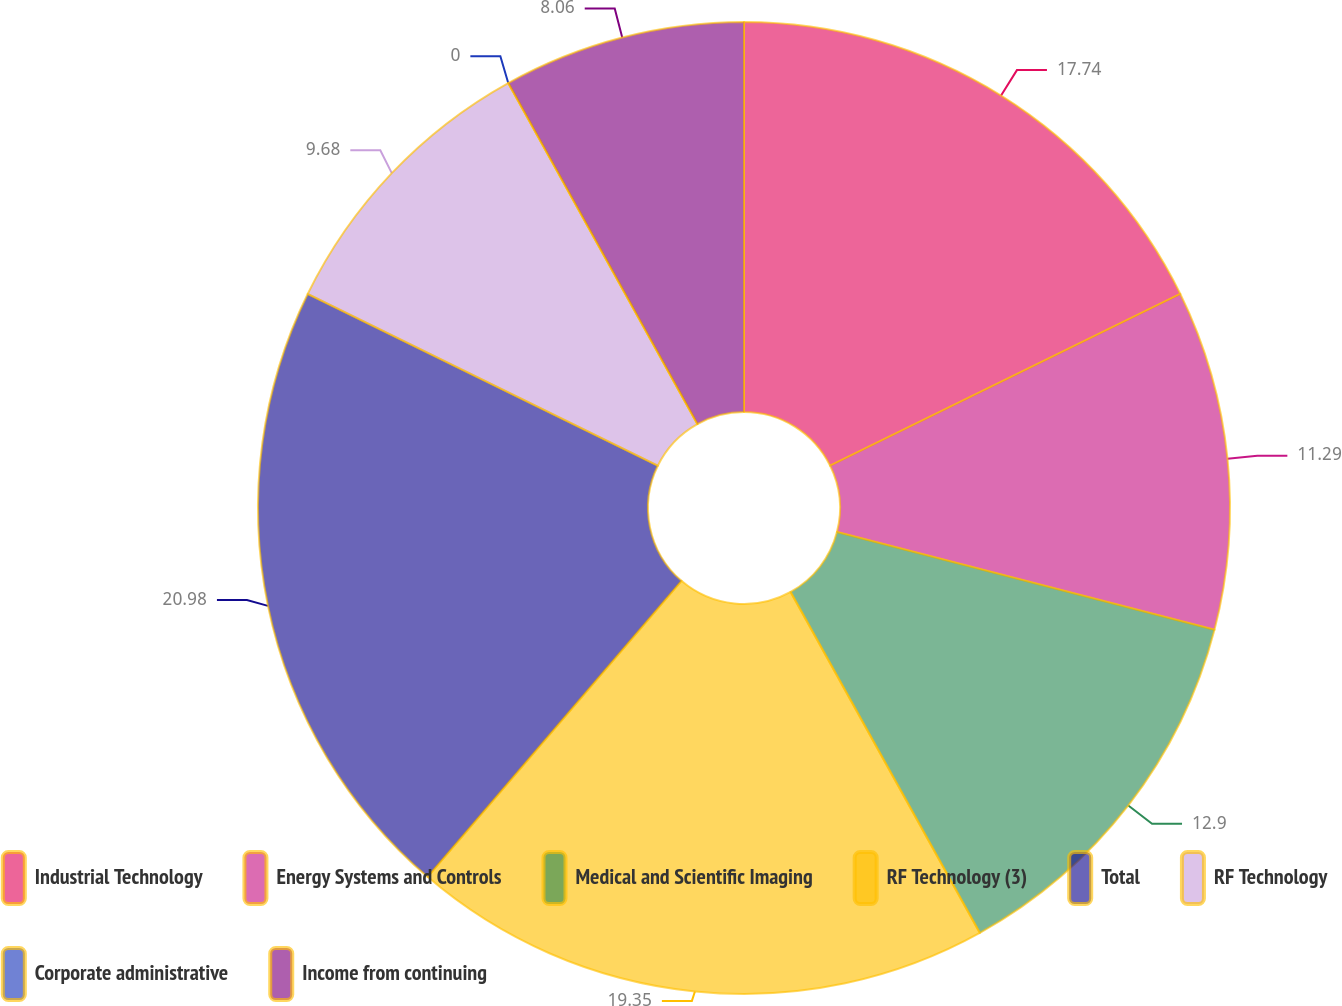Convert chart. <chart><loc_0><loc_0><loc_500><loc_500><pie_chart><fcel>Industrial Technology<fcel>Energy Systems and Controls<fcel>Medical and Scientific Imaging<fcel>RF Technology (3)<fcel>Total<fcel>RF Technology<fcel>Corporate administrative<fcel>Income from continuing<nl><fcel>17.74%<fcel>11.29%<fcel>12.9%<fcel>19.35%<fcel>20.97%<fcel>9.68%<fcel>0.0%<fcel>8.06%<nl></chart> 